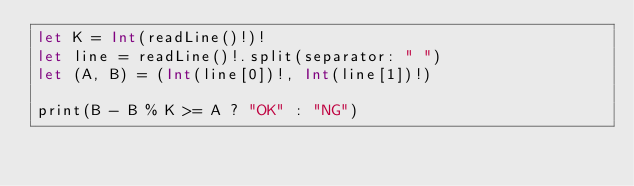Convert code to text. <code><loc_0><loc_0><loc_500><loc_500><_Swift_>let K = Int(readLine()!)!
let line = readLine()!.split(separator: " ")
let (A, B) = (Int(line[0])!, Int(line[1])!)

print(B - B % K >= A ? "OK" : "NG")
</code> 